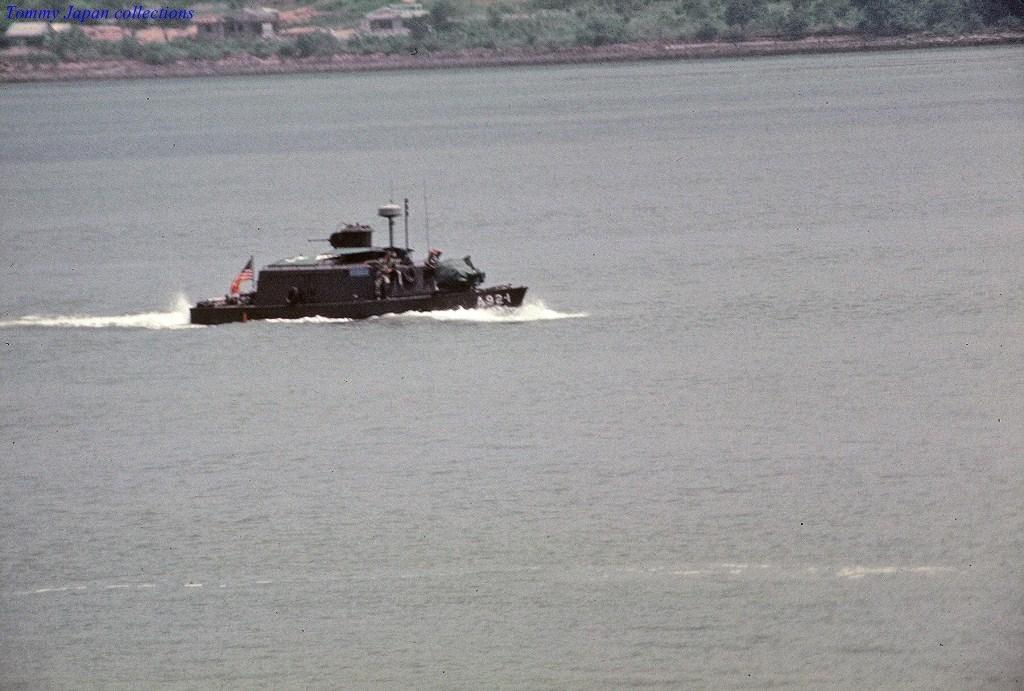What body of water is present in the image? There is a lake in the image. What is located in the lake? There is a ship in the lake. What can be seen in the background of the image? There are trees and buildings in the background of the image. What is written or displayed at the top of the image? There is some text visible at the top of the image. What type of discovery was made by the people on the ship in the image? There is no indication in the image of a discovery being made by the people on the ship. 